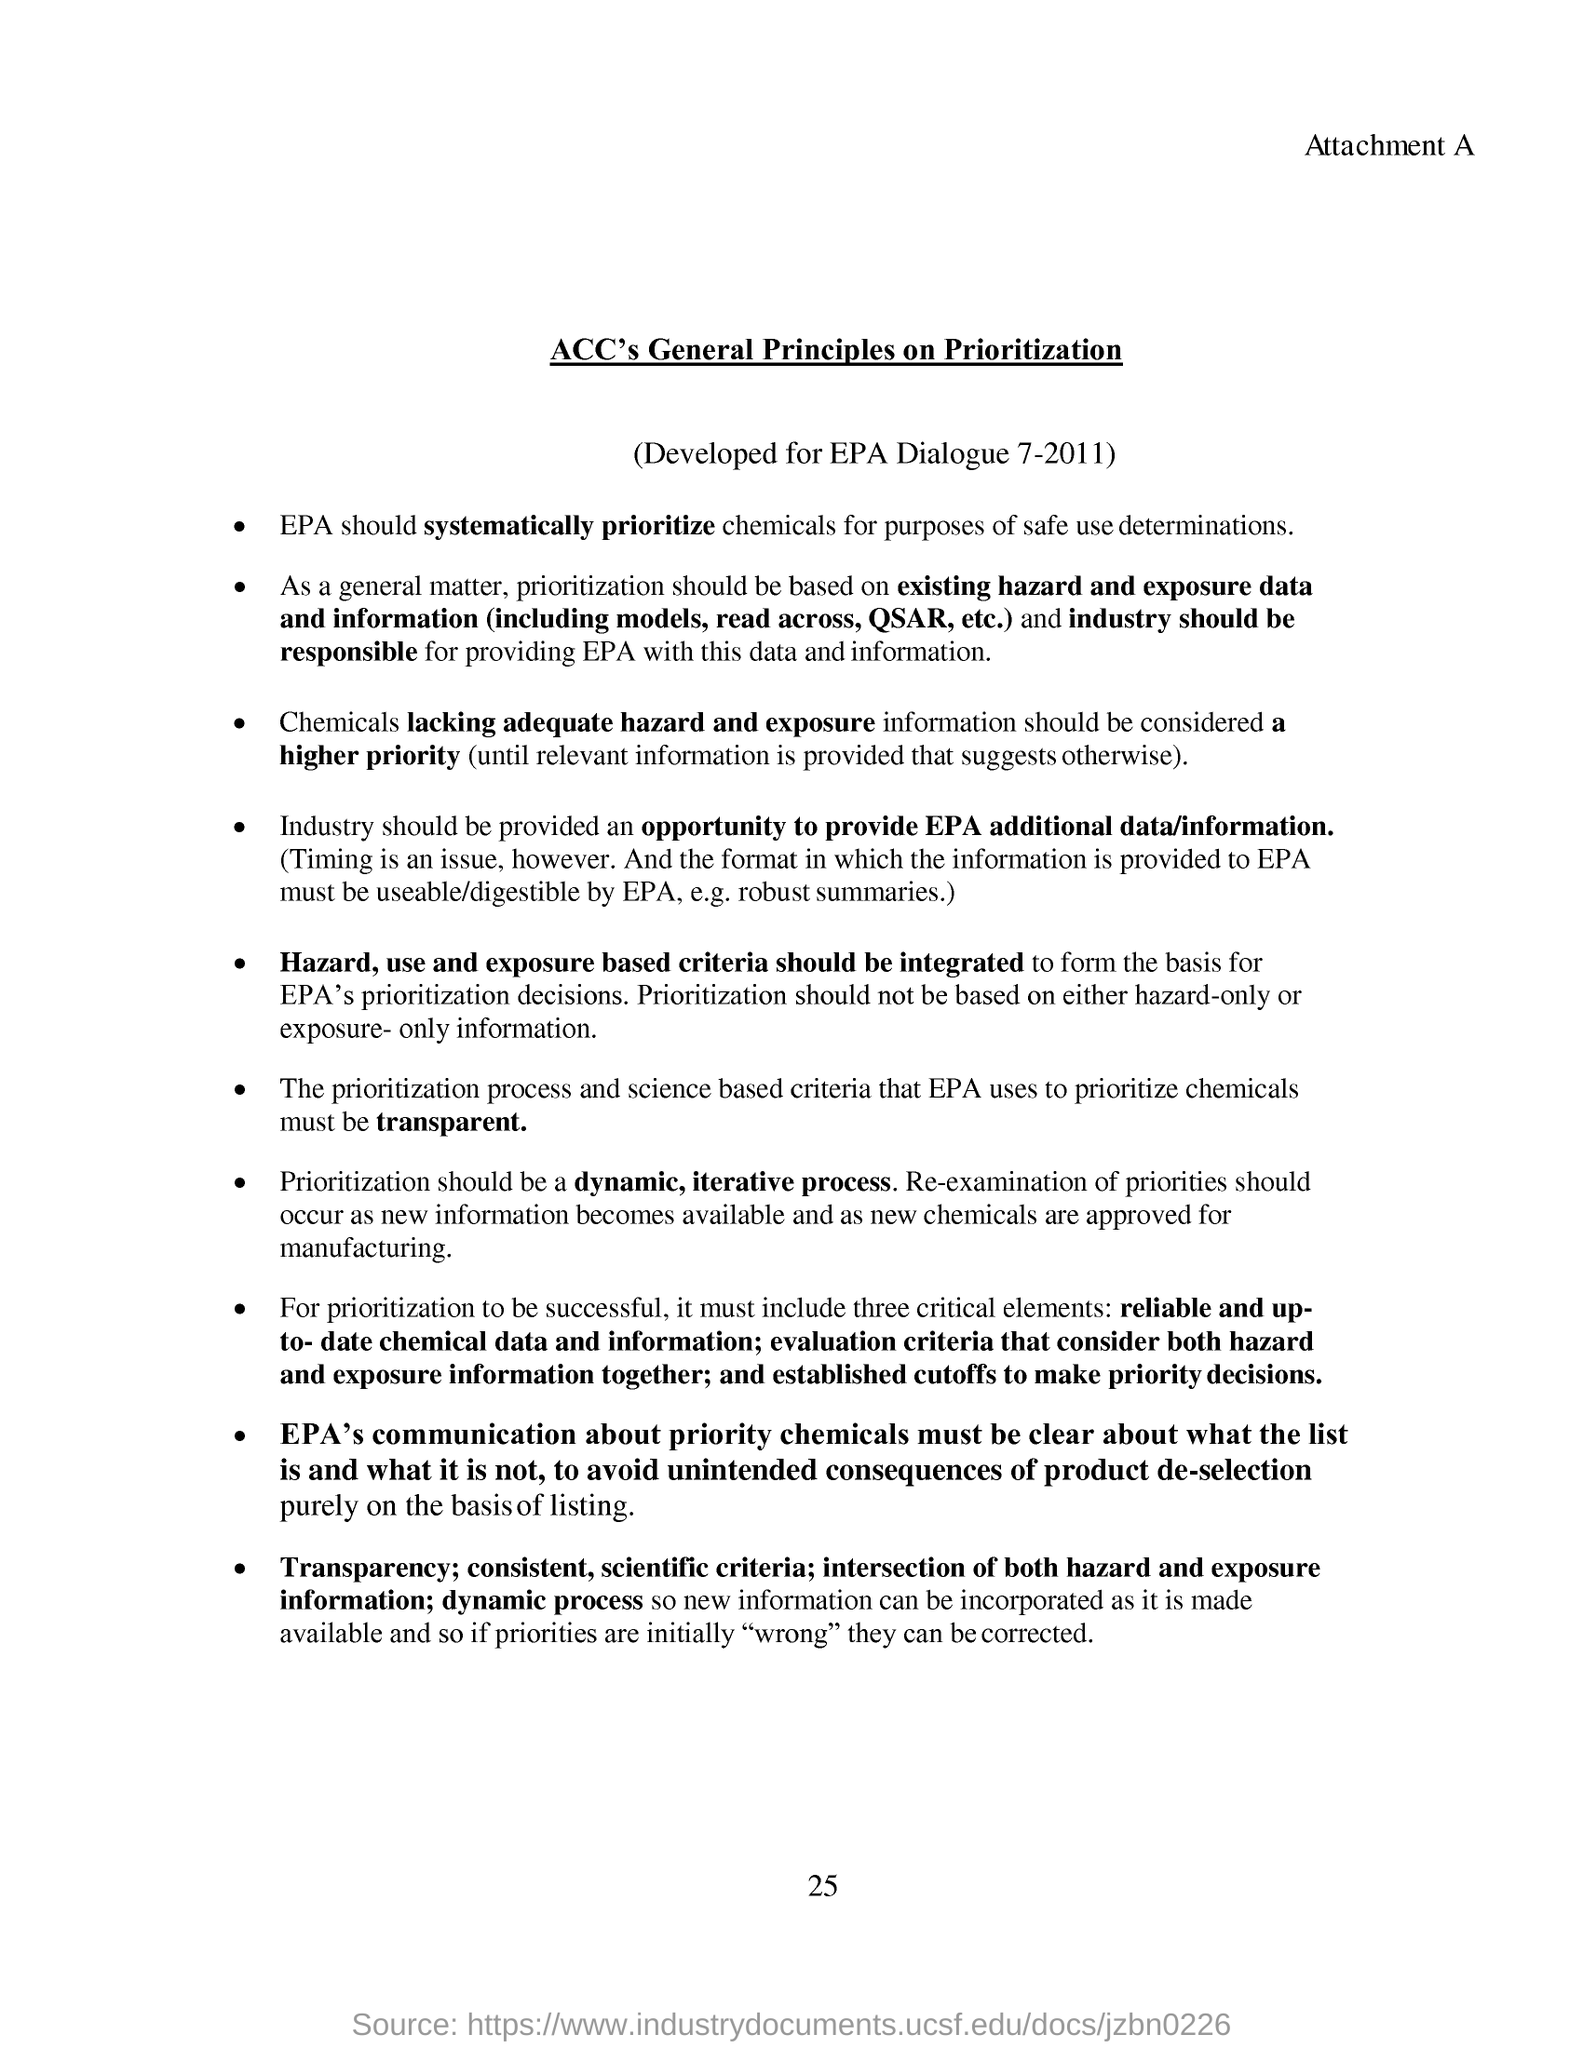List a handful of essential elements in this visual. It is crucial to prioritize reliable and up-to-date chemical data and information as the first point of critical elements for success in the field of sustainable chemistry. The prioritization process should be a dynamic and iterative one. Three critical elements are necessary for prioritization to be successful. This document is titled ACC's General Principles on Prioritization. The industry should be provided with an opportunity to provide additional data and information to the Environmental Protection Agency in order to better understand their needs and responsibilities. 